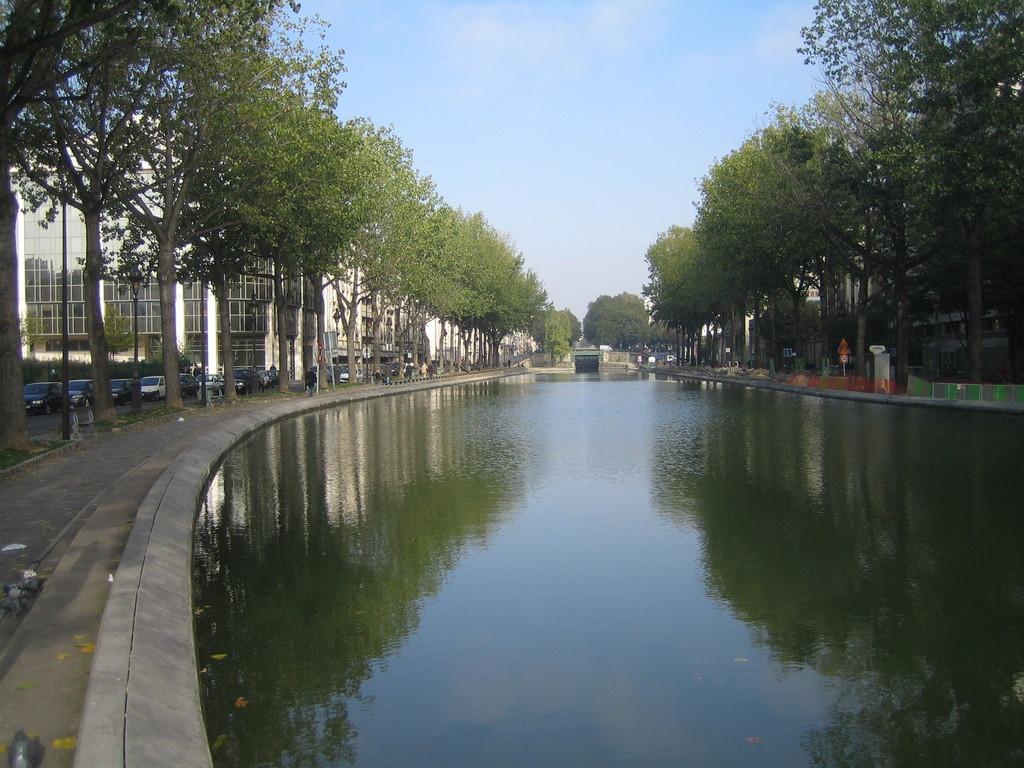Could you give a brief overview of what you see in this image? In this image I can see the water, the ground, few trees , few boards, a bridge, few vehicles on the road and few buildings. In the background I can see the sky. 